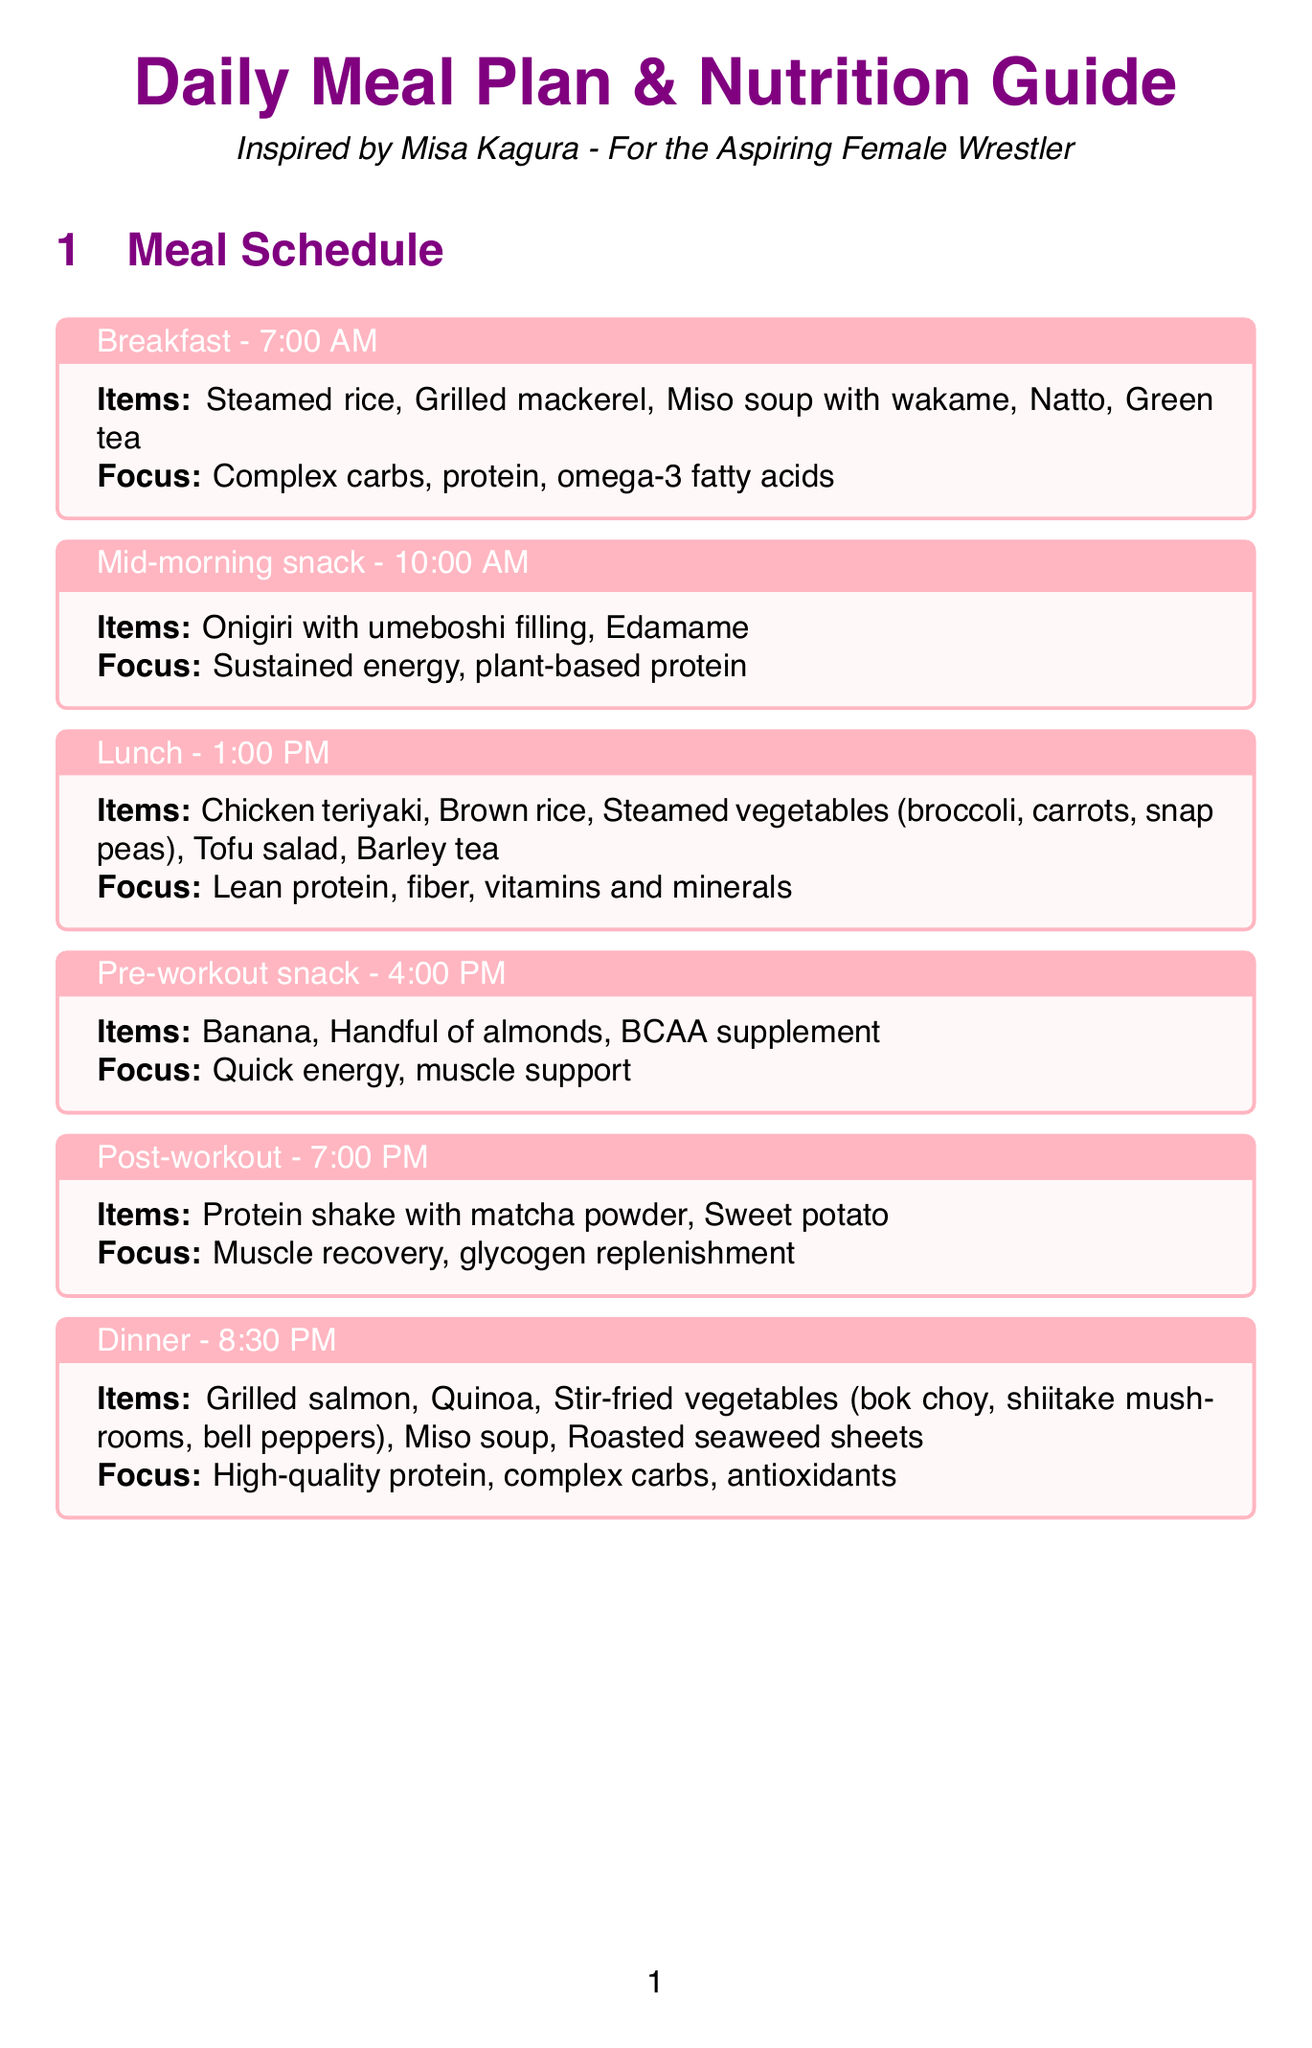What time is breakfast scheduled? Breakfast is scheduled for 7:00 AM as stated in the meal plan.
Answer: 7:00 AM How many liters of hydration is recommended per day? The document states that hydration should be 3-4 liters per day.
Answer: 3-4 liters What type of supplement is suggested to take post-workout? The document mentions that a protein shake with matcha powder is recommended for post-workout nutrition.
Answer: Protein shake with matcha powder What is the target protein intake per kg of body weight? The document specifies a target protein intake of 1.6-2.0 g per kg of body weight.
Answer: 1.6-2.0 g per kg What food items are included in the dinner meal plan? Dinner includes grilled salmon, quinoa, stir-fried vegetables, miso soup, and roasted seaweed sheets.
Answer: Grilled salmon, quinoa, stir-fried vegetables, miso soup, roasted seaweed sheets What is the focus of the pre-workout snack? The pre-workout snack focuses on quick energy and muscle support.
Answer: Quick energy, muscle support How many grams of creatine monohydrate is recommended daily? The document specifies a dosage of 5g daily for creatine monohydrate.
Answer: 5g What is advised for pre-match nutrition? For pre-match nutrition, it is advised to consume a meal rich in complex carbs and moderate protein 3-4 hours before a match.
Answer: Consume a meal rich in complex carbs and moderate protein 3-4 hours before a match 